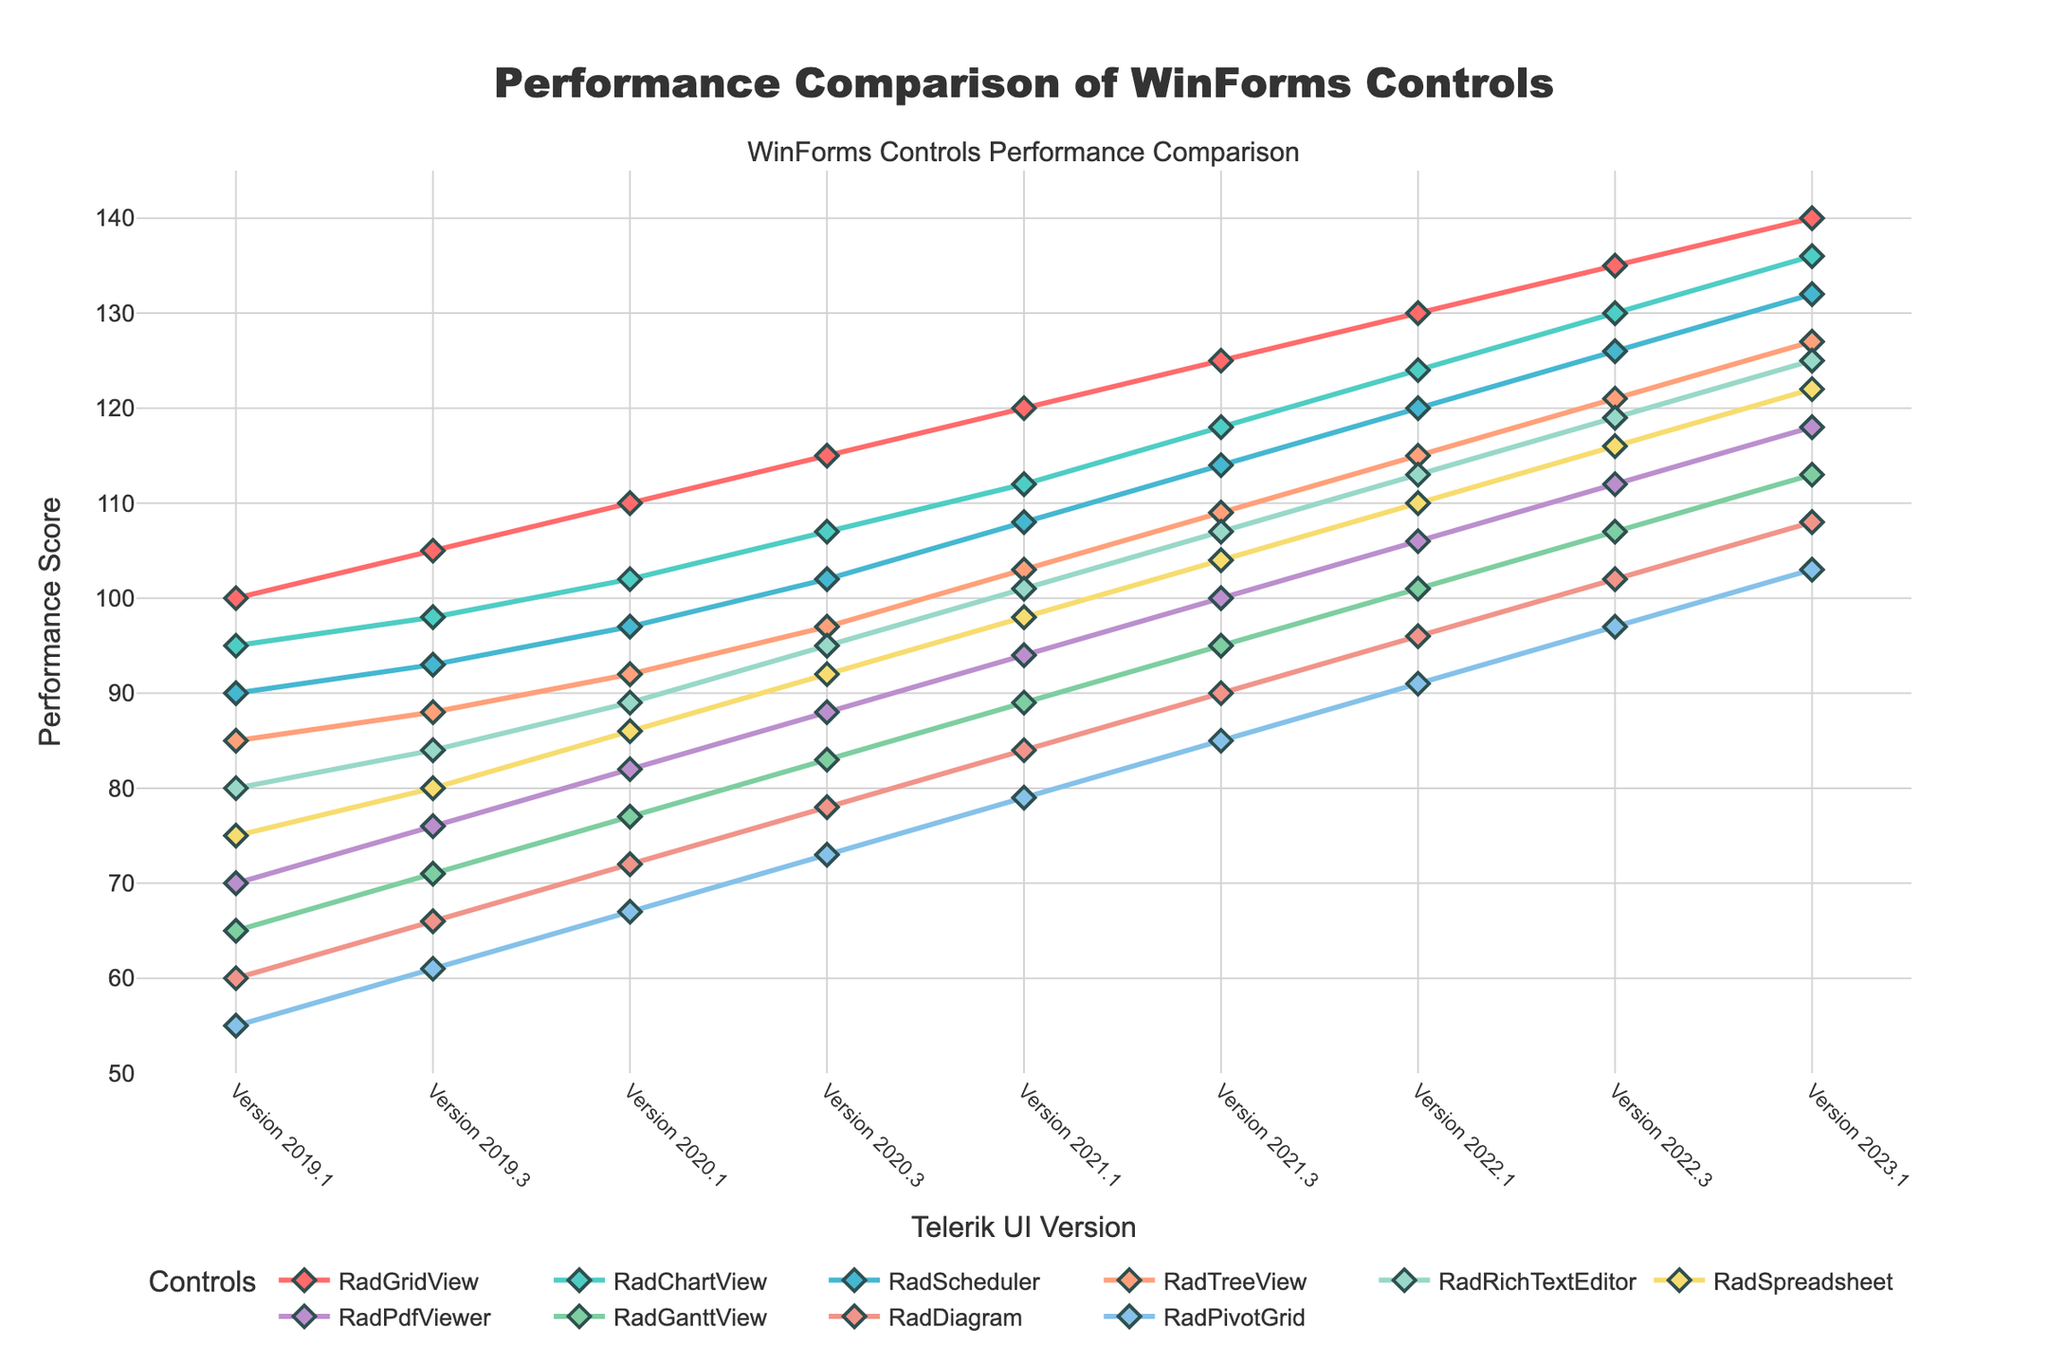What is the trend of RadGridView's performance over the versions? The performance score of RadGridView increases progressively from one version to the next, starting at 100 for Version 2019.1 and reaching 140 for Version 2023.1. Each version shows a consistent improvement in performance.
Answer: Increasing trend Which control has the highest performance score in Version 2023.1? By looking at the y-axis values for Version 2023.1, RadGridView has the highest performance score of 140 among all the controls listed.
Answer: RadGridView How does RadPivotGrid's performance score in Version 2021.1 compare to RadTreeView's performance score in the same version? The performance score for RadPivotGrid in Version 2021.1 is 79, and the score for RadTreeView in the same version is 103. By comparing these values, RadTreeView's score is higher.
Answer: RadTreeView is higher What is the average performance score of RadScheduler from Version 2019.1 to Version 2023.1? To compute the average, add the performance scores for RadScheduler (90, 93, 97, 102, 108, 114, 120, 126, 132) and divide by the number of versions (9). Sum = 1002, so average = 1002 / 9.
Answer: 111.33 Between Version 2019.3 and Version 2023.1, which control showed the greatest percentage increase in performance? Calculate percentage increase for each control: (final - initial) / initial * 100. RadDiagram showed the largest increase from 66 to 108, percentage increase is (108 - 66) / 66 * 100 = 63.64%. This is higher than other controls' percentage increases.
Answer: RadDiagram Considering the performance scores in Version 2022.1, which control has the score closest to 100? Identify the control with the performance score nearest to 100 in Version 2022.1. RadPdfViewer has the closest score of 106.
Answer: RadPdfViewer What is the difference in performance scores between Version 2020.3 and Version 2021.3 for RadRichTextEditor? To find the difference, subtract the performance score of Version 2020.3 (95) from Version 2021.3 (107). 107 - 95 = 12
Answer: 12 points What is the median performance score of all controls in Version 2020.1? List all performance scores for Version 2020.1 (110, 102, 97, 92, 89, 86, 82, 77, 72, 67) and find the middle value which is (89+86)/2.
Answer: 87.5 How does the performance trend of RadScheduler compare to RadTreeView across all versions? Both RadScheduler and RadTreeView show an increasing performance trend across all versions from 2019.1 to 2023.1. Although RadScheduler starts at a higher value and maintains a consistent lead over RadTreeView, both show parallel upward trends.
Answer: Both increasing, RadScheduler starts and remains higher Which control experiences the smallest improvement in performance from Version 2019.1 to Version 2023.1? Calculate the improvement for each control, and RadPivotGrid shows the smallest improvement of only 48 points, from 55 to 103.
Answer: RadPivotGrid 